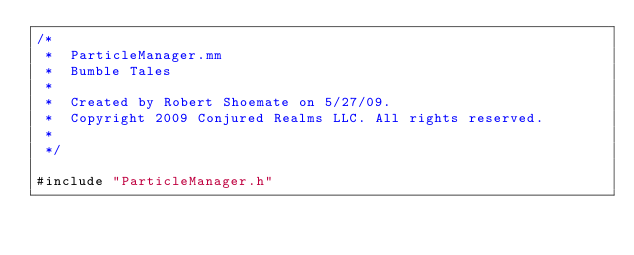<code> <loc_0><loc_0><loc_500><loc_500><_ObjectiveC_>/*
 *  ParticleManager.mm
 *  Bumble Tales
 *
 *  Created by Robert Shoemate on 5/27/09.
 *  Copyright 2009 Conjured Realms LLC. All rights reserved.
 *
 */

#include "ParticleManager.h"

</code> 